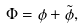<formula> <loc_0><loc_0><loc_500><loc_500>\Phi = \phi + \tilde { \phi } ,</formula> 